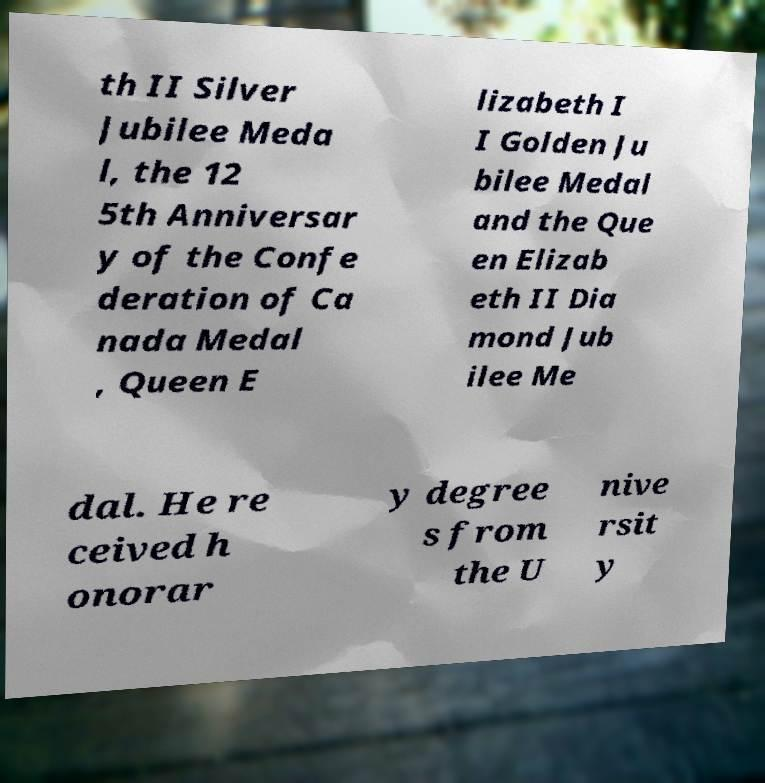What messages or text are displayed in this image? I need them in a readable, typed format. th II Silver Jubilee Meda l, the 12 5th Anniversar y of the Confe deration of Ca nada Medal , Queen E lizabeth I I Golden Ju bilee Medal and the Que en Elizab eth II Dia mond Jub ilee Me dal. He re ceived h onorar y degree s from the U nive rsit y 